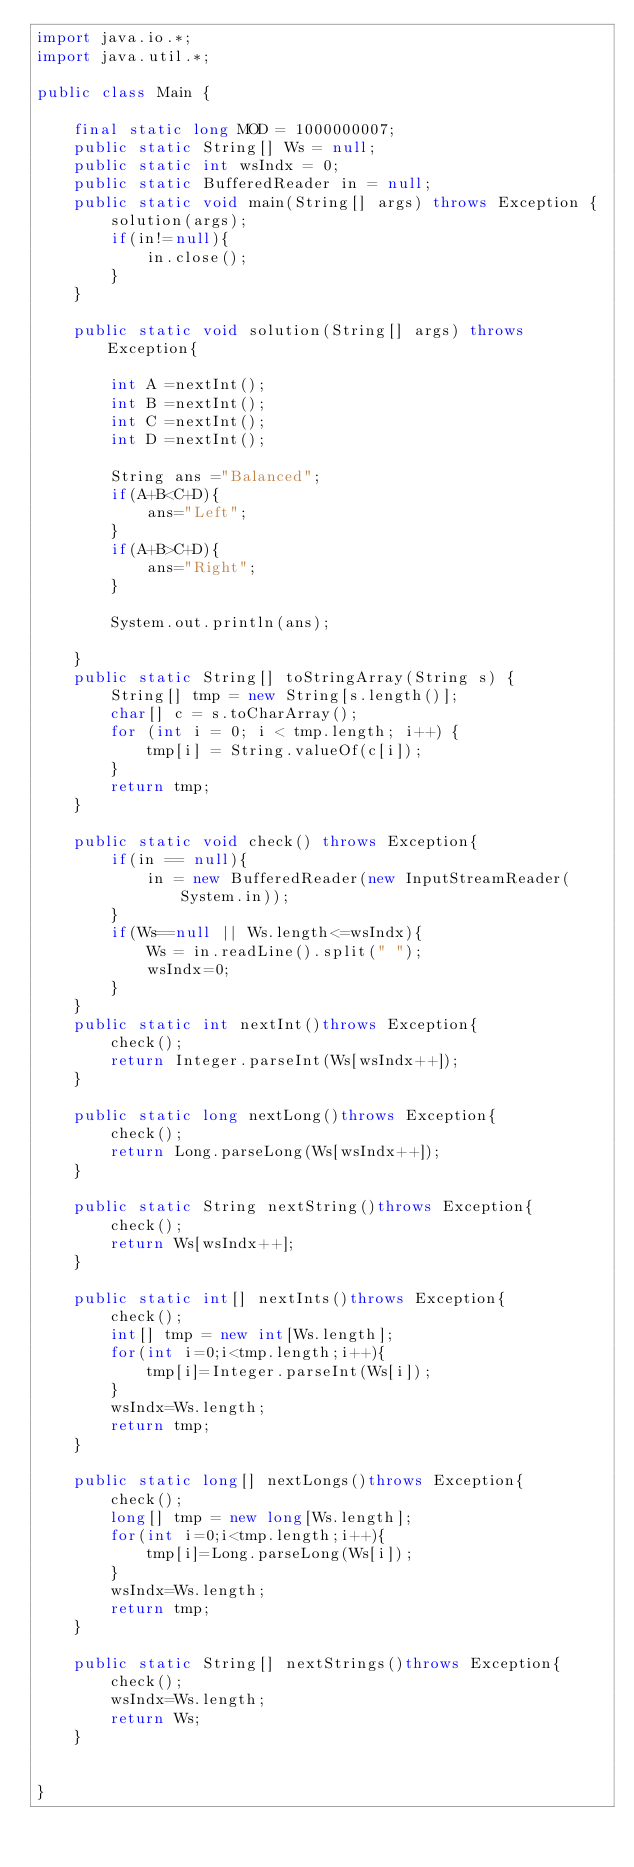Convert code to text. <code><loc_0><loc_0><loc_500><loc_500><_Java_>import java.io.*;
import java.util.*;

public class Main {

	final static long MOD = 1000000007;
	public static String[] Ws = null;
	public static int wsIndx = 0;
	public static BufferedReader in = null;
	public static void main(String[] args) throws Exception {
		solution(args);
		if(in!=null){
			in.close();
		}
	}

	public static void solution(String[] args) throws Exception{

		int A =nextInt();
		int B =nextInt();
		int C =nextInt();
		int D =nextInt();

		String ans ="Balanced";
		if(A+B<C+D){
			ans="Left";
		}
		if(A+B>C+D){
			ans="Right";
		}

		System.out.println(ans);

	}
	public static String[] toStringArray(String s) {
		String[] tmp = new String[s.length()];
		char[] c = s.toCharArray();
		for (int i = 0; i < tmp.length; i++) {
			tmp[i] = String.valueOf(c[i]);
		}
		return tmp;
	}

	public static void check() throws Exception{
		if(in == null){
			in = new BufferedReader(new InputStreamReader(System.in));
		}
		if(Ws==null || Ws.length<=wsIndx){
			Ws = in.readLine().split(" ");
			wsIndx=0;
		}
	}
	public static int nextInt()throws Exception{
		check();
		return Integer.parseInt(Ws[wsIndx++]);
	}

	public static long nextLong()throws Exception{
		check();
		return Long.parseLong(Ws[wsIndx++]);
	}

	public static String nextString()throws Exception{
		check();
		return Ws[wsIndx++];
	}

	public static int[] nextInts()throws Exception{
		check();
		int[] tmp = new int[Ws.length];
		for(int i=0;i<tmp.length;i++){
			tmp[i]=Integer.parseInt(Ws[i]);
		}
		wsIndx=Ws.length;
		return tmp;
	}

	public static long[] nextLongs()throws Exception{
		check();
		long[] tmp = new long[Ws.length];
		for(int i=0;i<tmp.length;i++){
			tmp[i]=Long.parseLong(Ws[i]);
		}
		wsIndx=Ws.length;
		return tmp;
	}

	public static String[] nextStrings()throws Exception{
		check();
		wsIndx=Ws.length;
		return Ws;
	}


}
</code> 